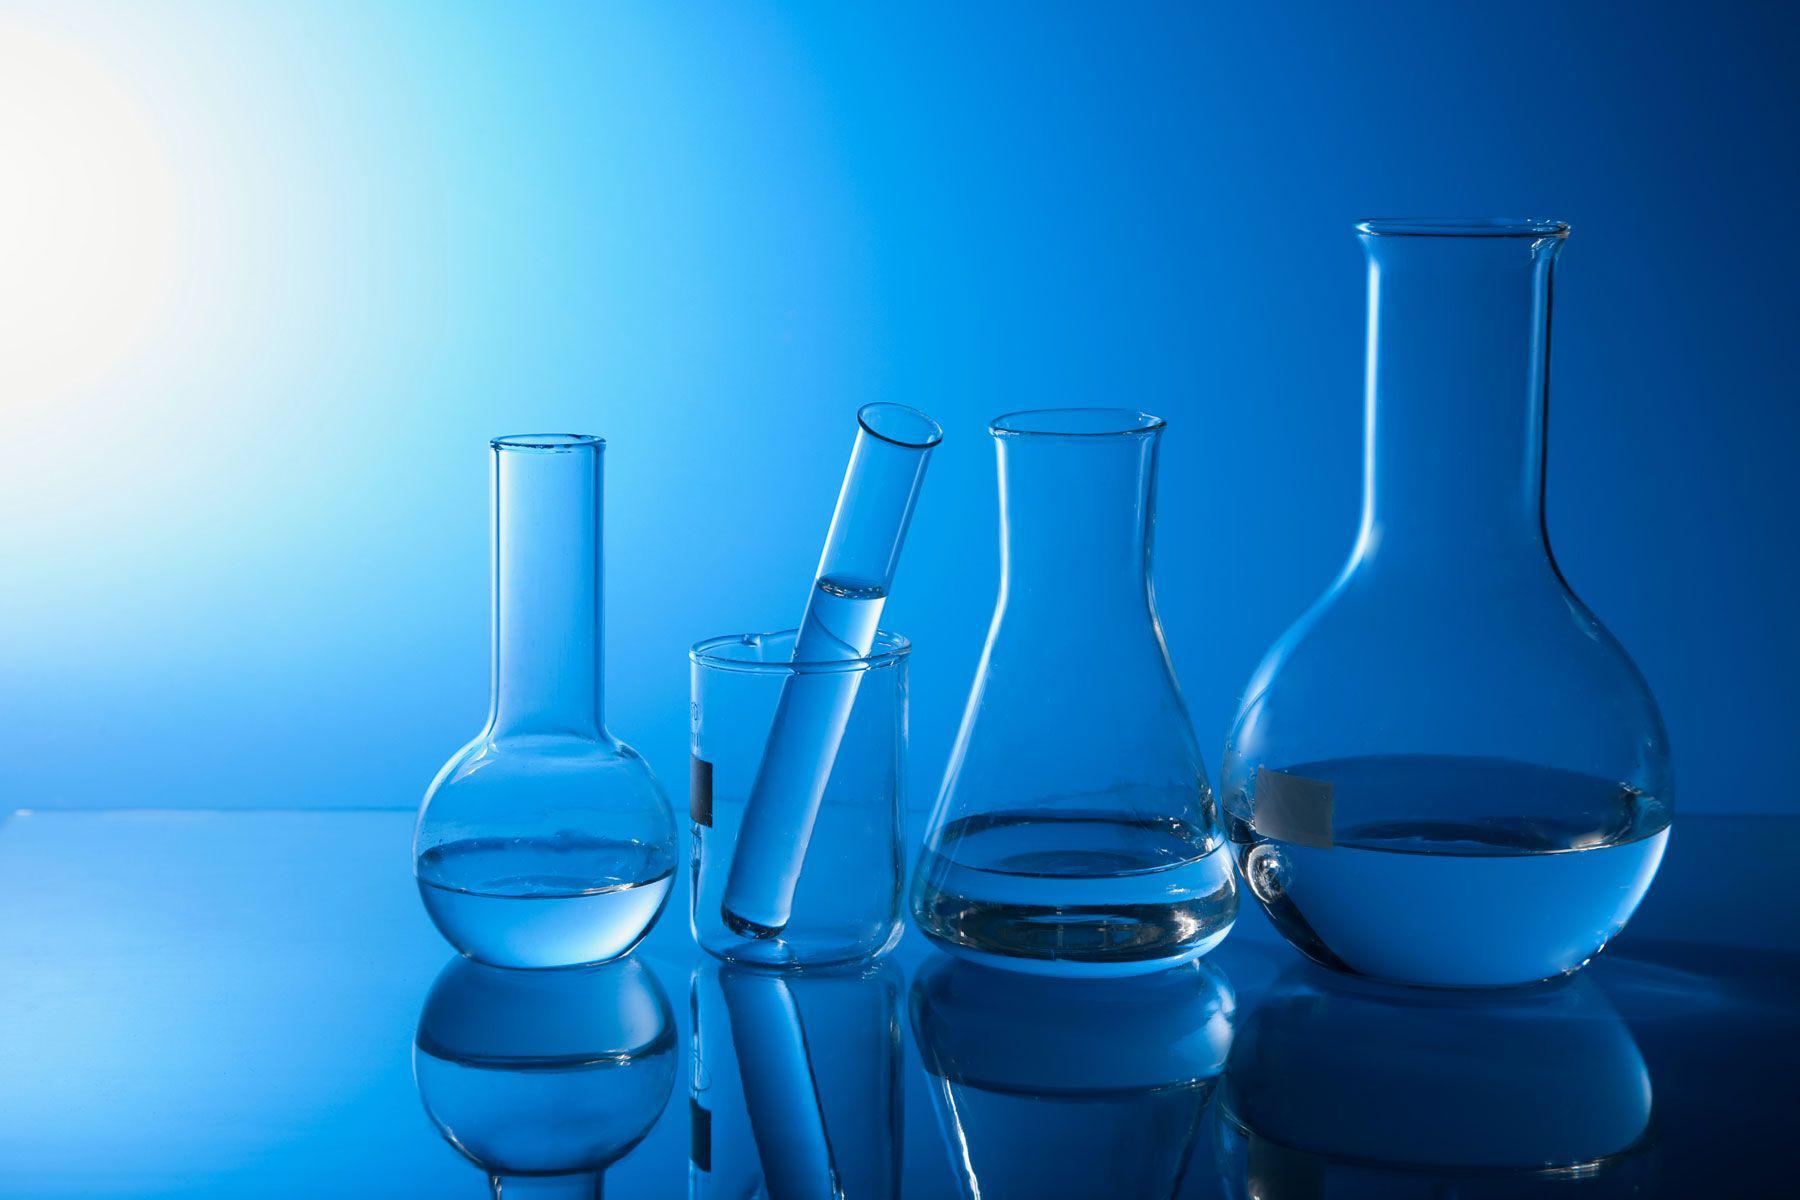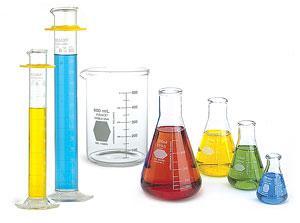The first image is the image on the left, the second image is the image on the right. Analyze the images presented: Is the assertion "All the containers have liquid in them." valid? Answer yes or no. No. 